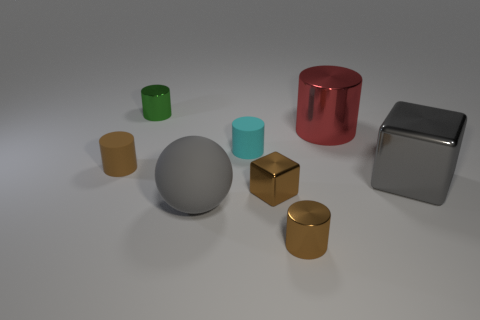How many matte objects are either balls or small cyan cylinders?
Provide a succinct answer. 2. Are there any large red cylinders that have the same material as the small cyan object?
Provide a short and direct response. No. What is the material of the red thing?
Make the answer very short. Metal. What shape is the large gray object to the right of the large gray thing that is on the left side of the rubber cylinder that is right of the brown rubber object?
Keep it short and to the point. Cube. Are there more gray spheres that are behind the brown block than gray metallic blocks?
Your response must be concise. No. There is a brown rubber thing; is it the same shape as the large object that is left of the big red metallic cylinder?
Make the answer very short. No. What is the shape of the large metallic thing that is the same color as the large ball?
Give a very brief answer. Cube. There is a small shiny cylinder that is behind the small rubber object that is behind the small brown matte cylinder; how many metallic cylinders are behind it?
Your response must be concise. 0. What is the color of the rubber object that is the same size as the gray metal object?
Offer a very short reply. Gray. How big is the rubber cylinder that is to the left of the matte cylinder on the right side of the large sphere?
Make the answer very short. Small. 